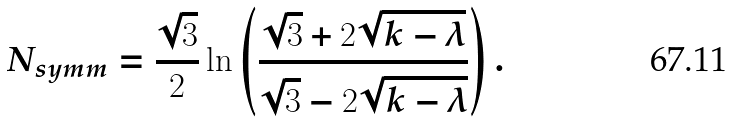Convert formula to latex. <formula><loc_0><loc_0><loc_500><loc_500>N _ { s y m m } = \frac { \sqrt { 3 } } { 2 } \ln \left ( \frac { \sqrt { 3 } + 2 \sqrt { k - \lambda } } { \sqrt { 3 } - 2 \sqrt { k - \lambda } } \right ) .</formula> 